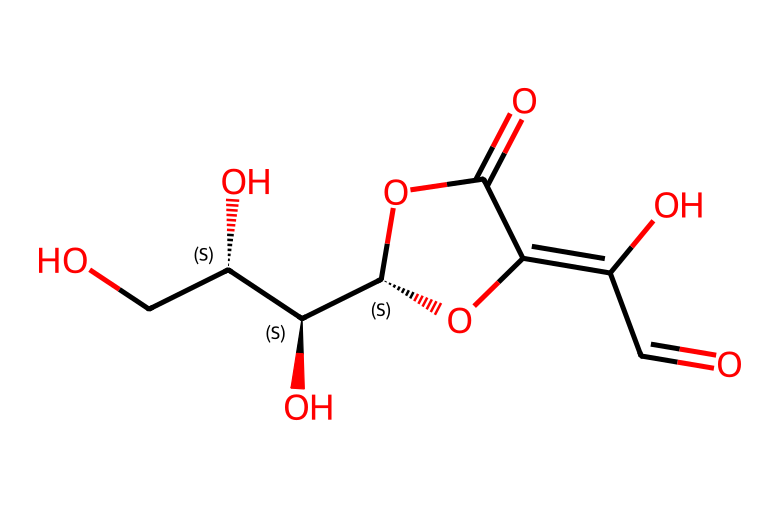What is the name of this chemical? By examining the structure and identifying the functional groups, we recognize that the presence of multiple hydroxyl (-OH) groups and a lactone indicates that this compound is ascorbic acid, commonly known as vitamin C.
Answer: ascorbic acid How many hydroxyl groups are present in this chemical? The structure shows three distinct -OH groups attached to the carbon backbone. By counting the -OH groups, we can conclude that there are three in total.
Answer: three What is the molecular formula of this compound? The molecular formula can be deduced from the structure by counting the number of each type of atom present. In this case, the correct count yields C6H8O6 as the molecular formula.
Answer: C6H8O6 What hybridization do the carbon atoms in the hydroxyl groups have? In the hydroxyl groups, the carbon atoms are sp3 hybridized due to the single bonds formed with surrounding atoms, leading to a tetrahedral geometry.
Answer: sp3 What role does ascorbic acid play in the human body? Ascorbic acid primarily serves as an antioxidant in the body, helping to neutralize free radicals and protecting against oxidative stress.
Answer: antioxidant How does ascorbic acid affect the oxidation of other compounds? Ascorbic acid can donate electrons to other molecules, thereby reducing them and preventing their oxidation, which is a key function in its role as an antioxidant.
Answer: reduces What type of compound is ascorbic acid primarily classified as? Ascorbic acid is classified as a water-soluble vitamin due to its high solubility in water, which is a characteristic of its carbon structure and functional groups.
Answer: water-soluble vitamin 